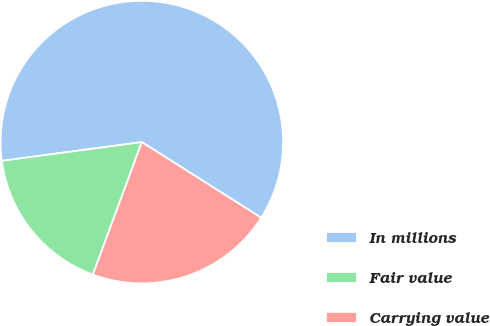Convert chart to OTSL. <chart><loc_0><loc_0><loc_500><loc_500><pie_chart><fcel>In millions<fcel>Fair value<fcel>Carrying value<nl><fcel>61.11%<fcel>17.25%<fcel>21.64%<nl></chart> 